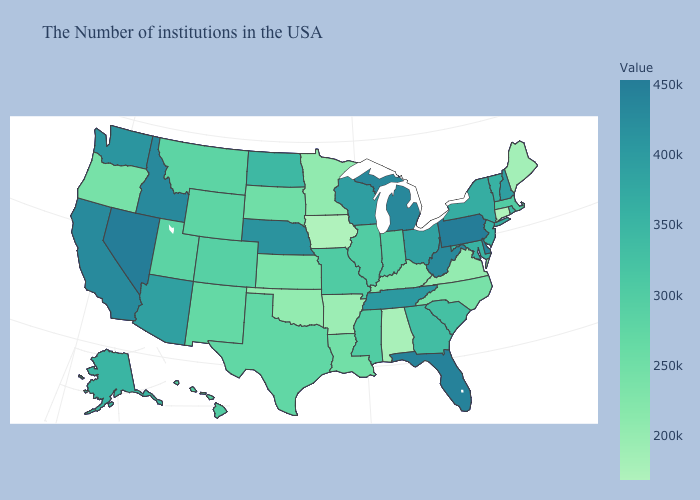Among the states that border New Mexico , which have the highest value?
Answer briefly. Arizona. Does Idaho have the lowest value in the USA?
Quick response, please. No. Which states have the highest value in the USA?
Keep it brief. Pennsylvania. Among the states that border Oregon , which have the lowest value?
Answer briefly. Washington. Is the legend a continuous bar?
Answer briefly. Yes. Does Vermont have the highest value in the Northeast?
Short answer required. No. Does South Dakota have the lowest value in the MidWest?
Write a very short answer. No. 